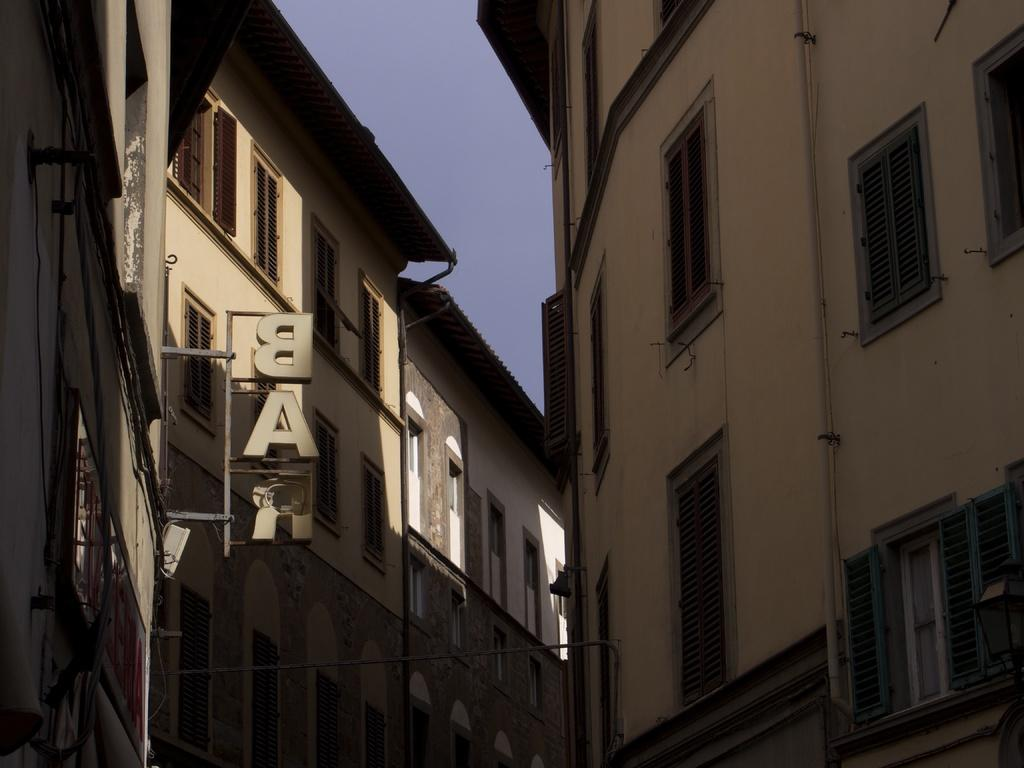What type of structures are visible in the image? There are buildings in the image. What feature do the buildings have? The buildings have windows. What else can be seen in the image besides the buildings? There is a stand with letters in the image. What type of language is being spoken by the celery in the image? There is no celery present in the image, and therefore no language being spoken by it. 